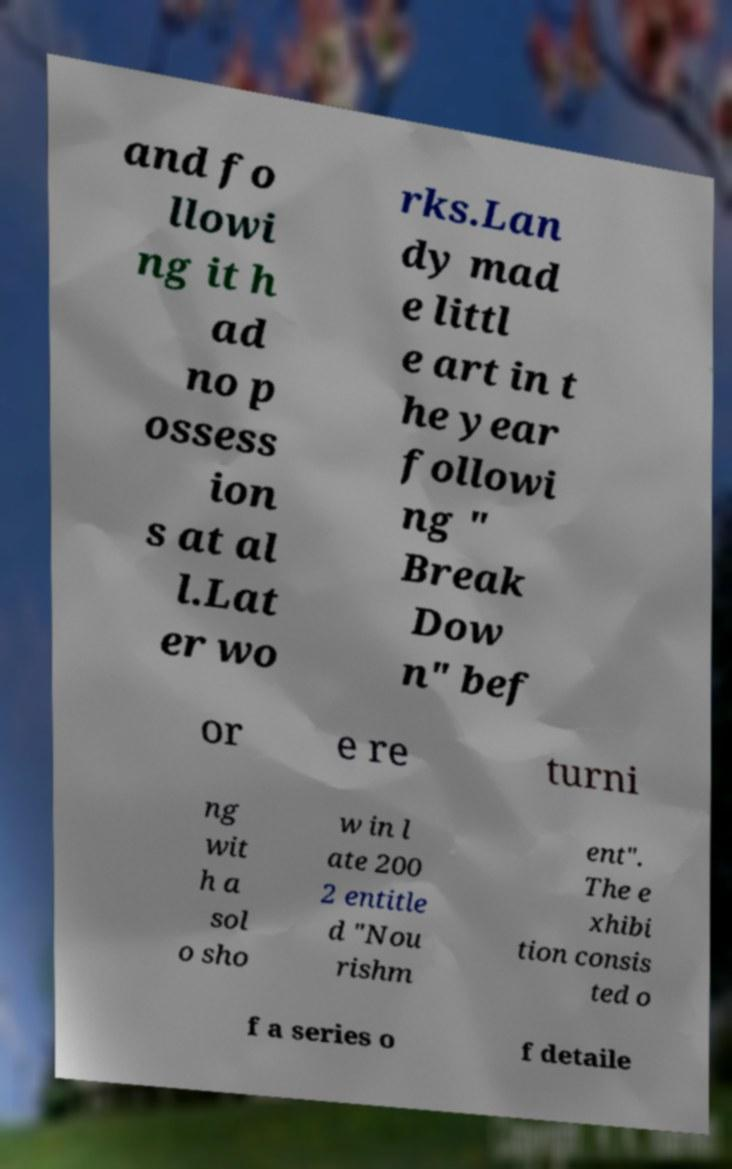There's text embedded in this image that I need extracted. Can you transcribe it verbatim? and fo llowi ng it h ad no p ossess ion s at al l.Lat er wo rks.Lan dy mad e littl e art in t he year followi ng " Break Dow n" bef or e re turni ng wit h a sol o sho w in l ate 200 2 entitle d "Nou rishm ent". The e xhibi tion consis ted o f a series o f detaile 